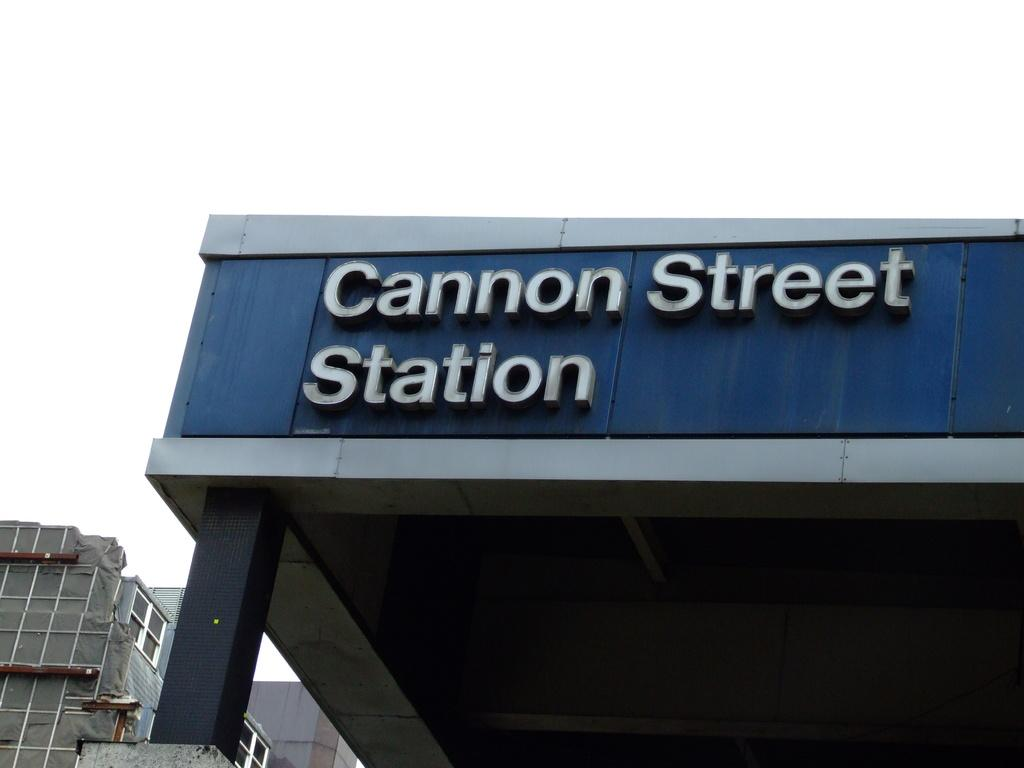What type of structures can be seen in the image? There are buildings in the image. What part of the natural environment is visible in the image? The sky is visible in the image. What type of approval is required to rub the buildings in the image? There is no mention of rubbing the buildings in the image, and therefore no approval is needed for such an action. 